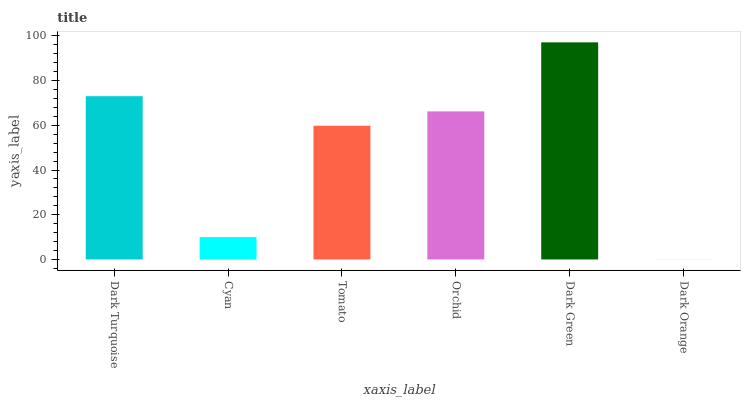Is Dark Orange the minimum?
Answer yes or no. Yes. Is Dark Green the maximum?
Answer yes or no. Yes. Is Cyan the minimum?
Answer yes or no. No. Is Cyan the maximum?
Answer yes or no. No. Is Dark Turquoise greater than Cyan?
Answer yes or no. Yes. Is Cyan less than Dark Turquoise?
Answer yes or no. Yes. Is Cyan greater than Dark Turquoise?
Answer yes or no. No. Is Dark Turquoise less than Cyan?
Answer yes or no. No. Is Orchid the high median?
Answer yes or no. Yes. Is Tomato the low median?
Answer yes or no. Yes. Is Dark Turquoise the high median?
Answer yes or no. No. Is Dark Green the low median?
Answer yes or no. No. 